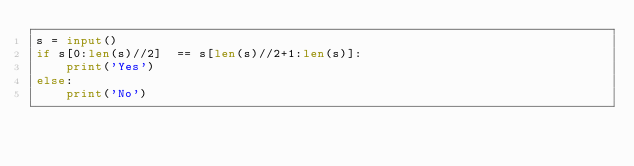Convert code to text. <code><loc_0><loc_0><loc_500><loc_500><_Python_>s = input()
if s[0:len(s)//2]  == s[len(s)//2+1:len(s)]:
    print('Yes')
else:
    print('No')</code> 